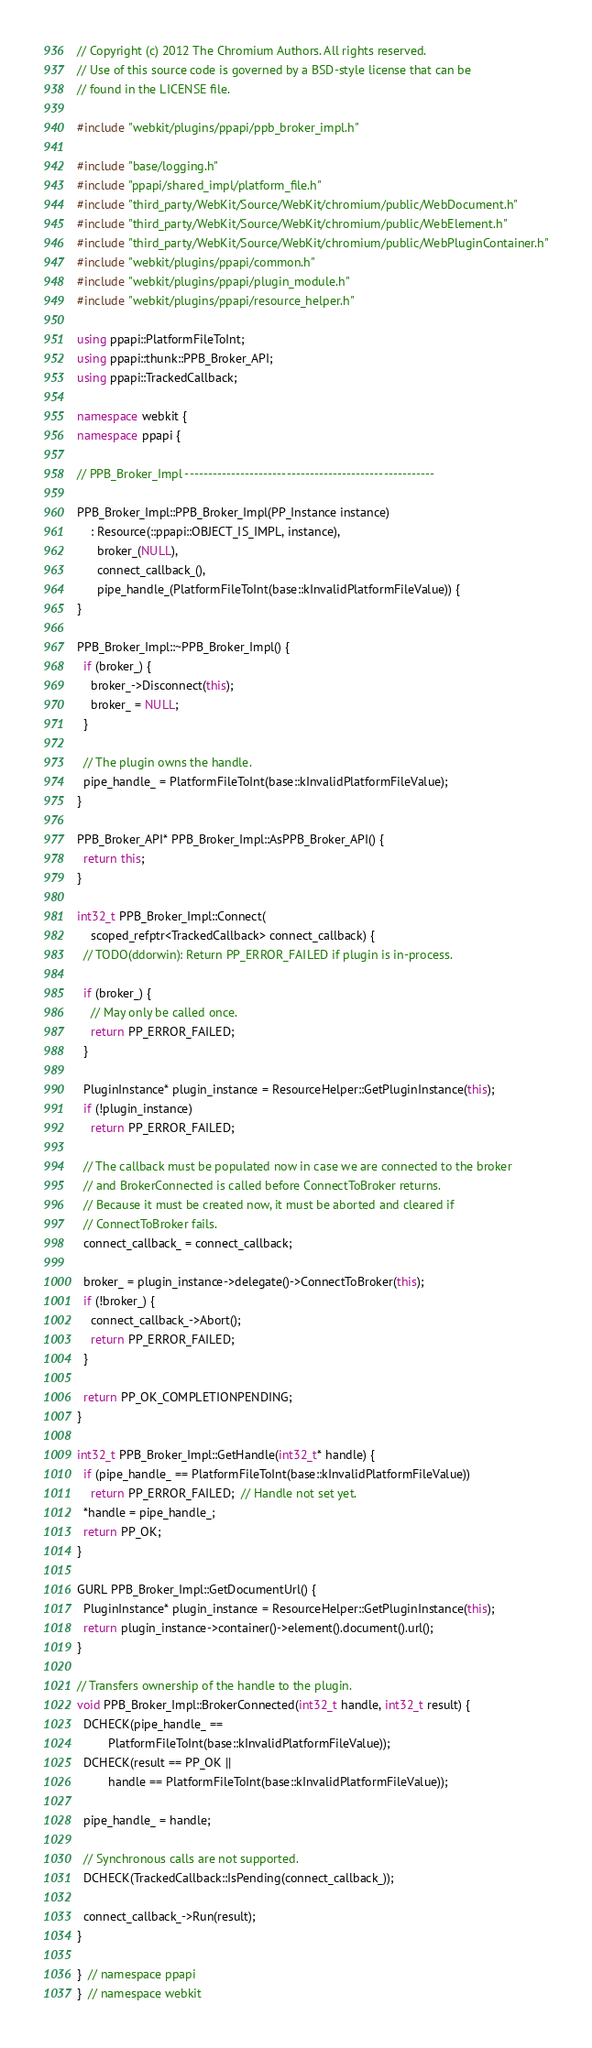Convert code to text. <code><loc_0><loc_0><loc_500><loc_500><_C++_>// Copyright (c) 2012 The Chromium Authors. All rights reserved.
// Use of this source code is governed by a BSD-style license that can be
// found in the LICENSE file.

#include "webkit/plugins/ppapi/ppb_broker_impl.h"

#include "base/logging.h"
#include "ppapi/shared_impl/platform_file.h"
#include "third_party/WebKit/Source/WebKit/chromium/public/WebDocument.h"
#include "third_party/WebKit/Source/WebKit/chromium/public/WebElement.h"
#include "third_party/WebKit/Source/WebKit/chromium/public/WebPluginContainer.h"
#include "webkit/plugins/ppapi/common.h"
#include "webkit/plugins/ppapi/plugin_module.h"
#include "webkit/plugins/ppapi/resource_helper.h"

using ppapi::PlatformFileToInt;
using ppapi::thunk::PPB_Broker_API;
using ppapi::TrackedCallback;

namespace webkit {
namespace ppapi {

// PPB_Broker_Impl ------------------------------------------------------

PPB_Broker_Impl::PPB_Broker_Impl(PP_Instance instance)
    : Resource(::ppapi::OBJECT_IS_IMPL, instance),
      broker_(NULL),
      connect_callback_(),
      pipe_handle_(PlatformFileToInt(base::kInvalidPlatformFileValue)) {
}

PPB_Broker_Impl::~PPB_Broker_Impl() {
  if (broker_) {
    broker_->Disconnect(this);
    broker_ = NULL;
  }

  // The plugin owns the handle.
  pipe_handle_ = PlatformFileToInt(base::kInvalidPlatformFileValue);
}

PPB_Broker_API* PPB_Broker_Impl::AsPPB_Broker_API() {
  return this;
}

int32_t PPB_Broker_Impl::Connect(
    scoped_refptr<TrackedCallback> connect_callback) {
  // TODO(ddorwin): Return PP_ERROR_FAILED if plugin is in-process.

  if (broker_) {
    // May only be called once.
    return PP_ERROR_FAILED;
  }

  PluginInstance* plugin_instance = ResourceHelper::GetPluginInstance(this);
  if (!plugin_instance)
    return PP_ERROR_FAILED;

  // The callback must be populated now in case we are connected to the broker
  // and BrokerConnected is called before ConnectToBroker returns.
  // Because it must be created now, it must be aborted and cleared if
  // ConnectToBroker fails.
  connect_callback_ = connect_callback;

  broker_ = plugin_instance->delegate()->ConnectToBroker(this);
  if (!broker_) {
    connect_callback_->Abort();
    return PP_ERROR_FAILED;
  }

  return PP_OK_COMPLETIONPENDING;
}

int32_t PPB_Broker_Impl::GetHandle(int32_t* handle) {
  if (pipe_handle_ == PlatformFileToInt(base::kInvalidPlatformFileValue))
    return PP_ERROR_FAILED;  // Handle not set yet.
  *handle = pipe_handle_;
  return PP_OK;
}

GURL PPB_Broker_Impl::GetDocumentUrl() {
  PluginInstance* plugin_instance = ResourceHelper::GetPluginInstance(this);
  return plugin_instance->container()->element().document().url();
}

// Transfers ownership of the handle to the plugin.
void PPB_Broker_Impl::BrokerConnected(int32_t handle, int32_t result) {
  DCHECK(pipe_handle_ ==
         PlatformFileToInt(base::kInvalidPlatformFileValue));
  DCHECK(result == PP_OK ||
         handle == PlatformFileToInt(base::kInvalidPlatformFileValue));

  pipe_handle_ = handle;

  // Synchronous calls are not supported.
  DCHECK(TrackedCallback::IsPending(connect_callback_));

  connect_callback_->Run(result);
}

}  // namespace ppapi
}  // namespace webkit
</code> 